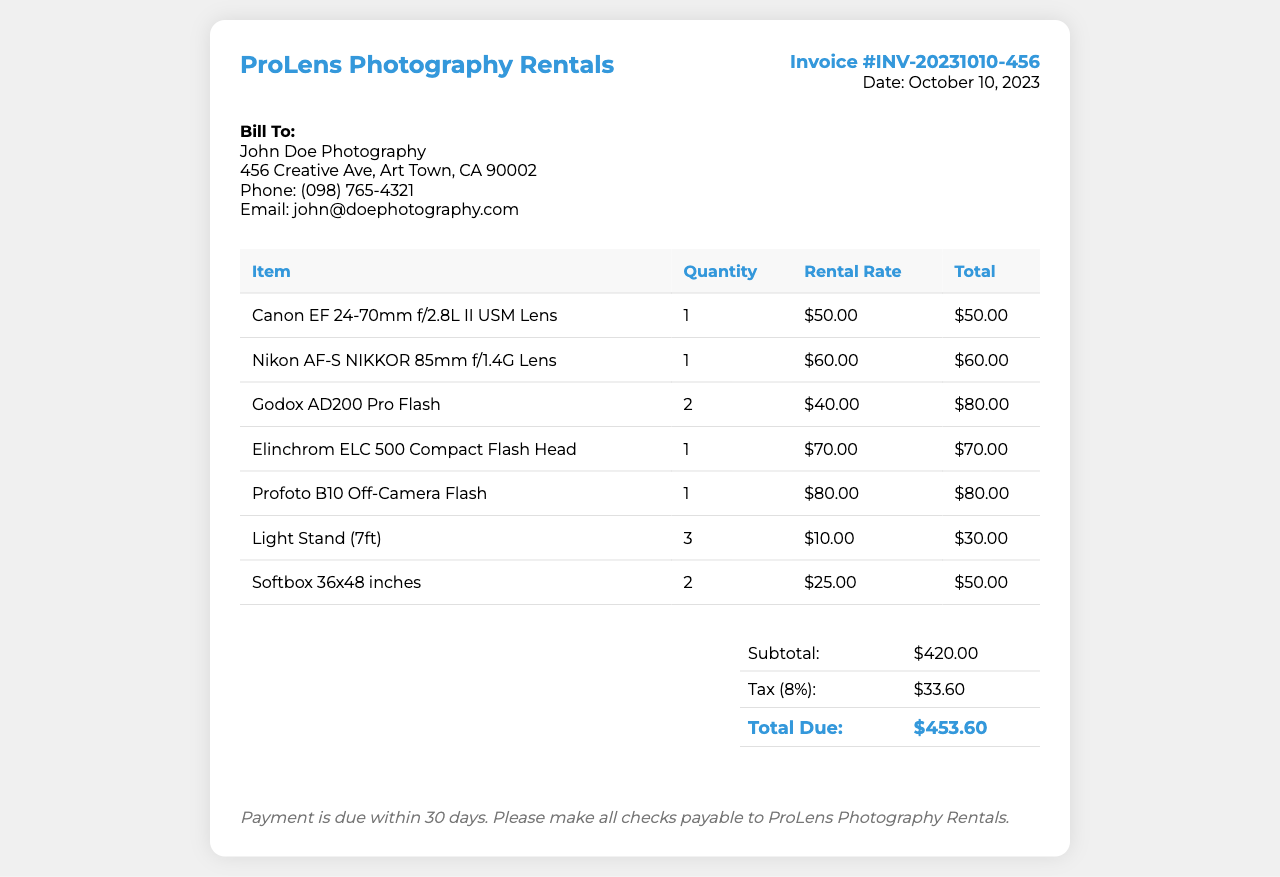What is the invoice number? The invoice number is listed at the top right corner of the document.
Answer: INV-20231010-456 Who is the invoice billed to? The billing information is provided in the client details section.
Answer: John Doe Photography What is the total due amount? The total due is calculated in the summary table at the end of the document.
Answer: $453.60 How many Canon lenses are rented? The document lists the number of each item rented in the table.
Answer: 1 What is the rental rate for the Nikon lens? The rental rate for the Nikon lens is shown in the table under the corresponding item.
Answer: $60.00 What is the subtotal before tax? The subtotal is shown in the summary table as the total amount before tax is added.
Answer: $420.00 How many softboxes are rented? The quantity for the softbox rental is provided in the table.
Answer: 2 What is the tax percentage applied? The tax percentage is mentioned in the summary section.
Answer: 8% When is the payment due? The payment terms are provided at the end of the document.
Answer: Within 30 days 